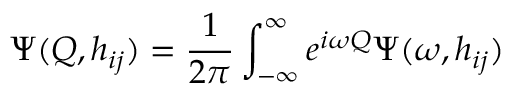<formula> <loc_0><loc_0><loc_500><loc_500>\Psi ( Q , h _ { i j } ) = \frac { 1 } { 2 \pi } \int _ { - \infty } ^ { \infty } e ^ { i \omega Q } \Psi ( \omega , h _ { i j } )</formula> 